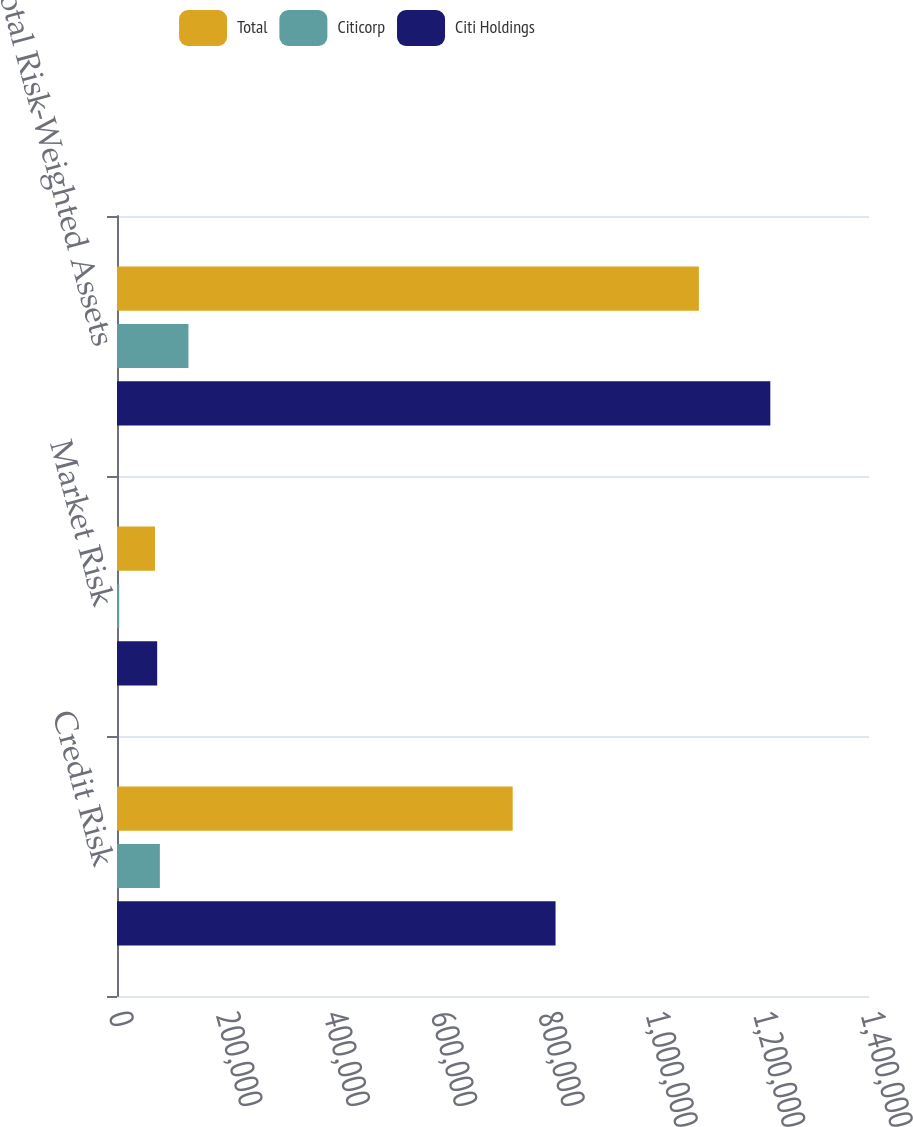Convert chart to OTSL. <chart><loc_0><loc_0><loc_500><loc_500><stacked_bar_chart><ecel><fcel>Credit Risk<fcel>Market Risk<fcel>Total Risk-Weighted Assets<nl><fcel>Total<fcel>736641<fcel>70715<fcel>1.08328e+06<nl><fcel>Citicorp<fcel>79819<fcel>4102<fcel>133000<nl><fcel>Citi Holdings<fcel>816460<fcel>74817<fcel>1.21628e+06<nl></chart> 